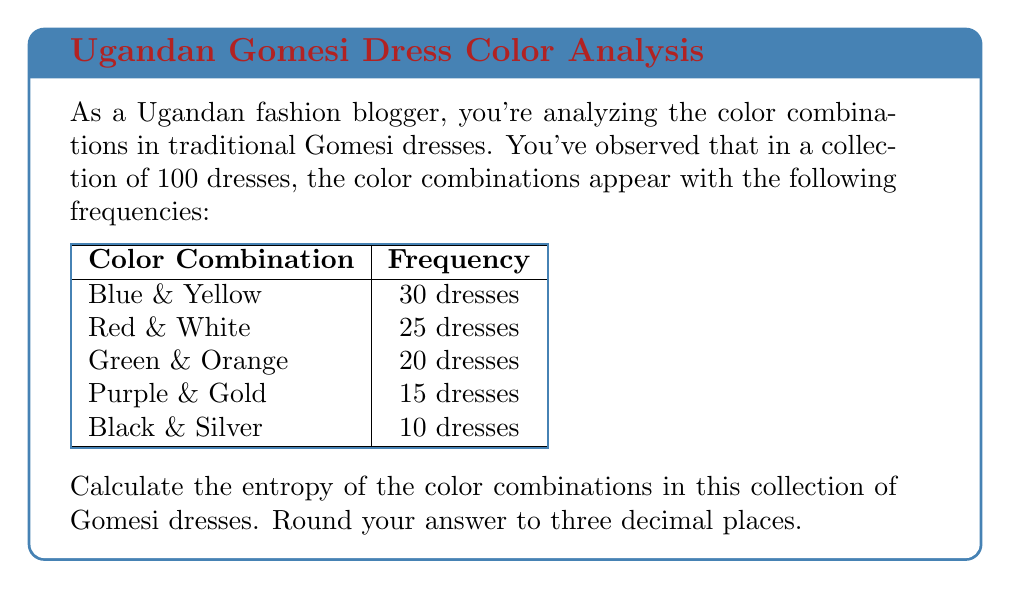What is the answer to this math problem? To calculate the entropy of the color combinations, we'll use the formula:

$$H = -\sum_{i=1}^n p_i \log_2(p_i)$$

Where $H$ is the entropy, $p_i$ is the probability of each color combination, and $n$ is the number of different color combinations.

Step 1: Calculate the probabilities for each color combination:
- Blue & Yellow: $p_1 = 30/100 = 0.3$
- Red & White: $p_2 = 25/100 = 0.25$
- Green & Orange: $p_3 = 20/100 = 0.2$
- Purple & Gold: $p_4 = 15/100 = 0.15$
- Black & Silver: $p_5 = 10/100 = 0.1$

Step 2: Calculate each term of the sum:
- $-0.3 \log_2(0.3) = 0.521$
- $-0.25 \log_2(0.25) = 0.5$
- $-0.2 \log_2(0.2) = 0.464$
- $-0.15 \log_2(0.15) = 0.411$
- $-0.1 \log_2(0.1) = 0.332$

Step 3: Sum up all terms:
$$H = 0.521 + 0.5 + 0.464 + 0.411 + 0.332 = 2.228$$

Step 4: Round to three decimal places:
$$H \approx 2.228$$
Answer: 2.228 bits 